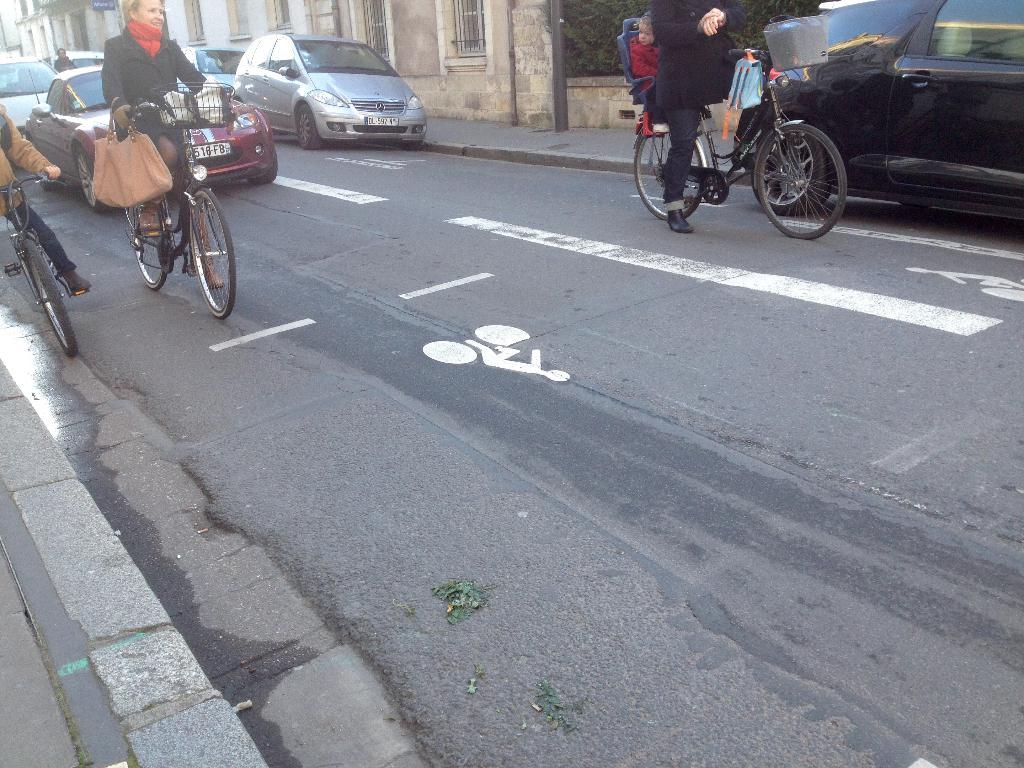How many people are in the image? There are three persons in the image. What are the persons doing in the image? The persons are carrying bags and riding bicycles. Where are the bicycles located in the image? The bicycles are on a road. What else can be seen on the road in the image? Cars are present on the same road. What is beside the road in the image? There is a footpath beside the road. What type of structure is visible in the image? There is a building with windows in the image. What type of polish is being applied to the bicycles in the image? There is no indication in the image that any polish is being applied to the bicycles. Can you see any clouds in the sky in the image? The provided facts do not mention the sky or clouds, so we cannot determine if they are present in the image. 